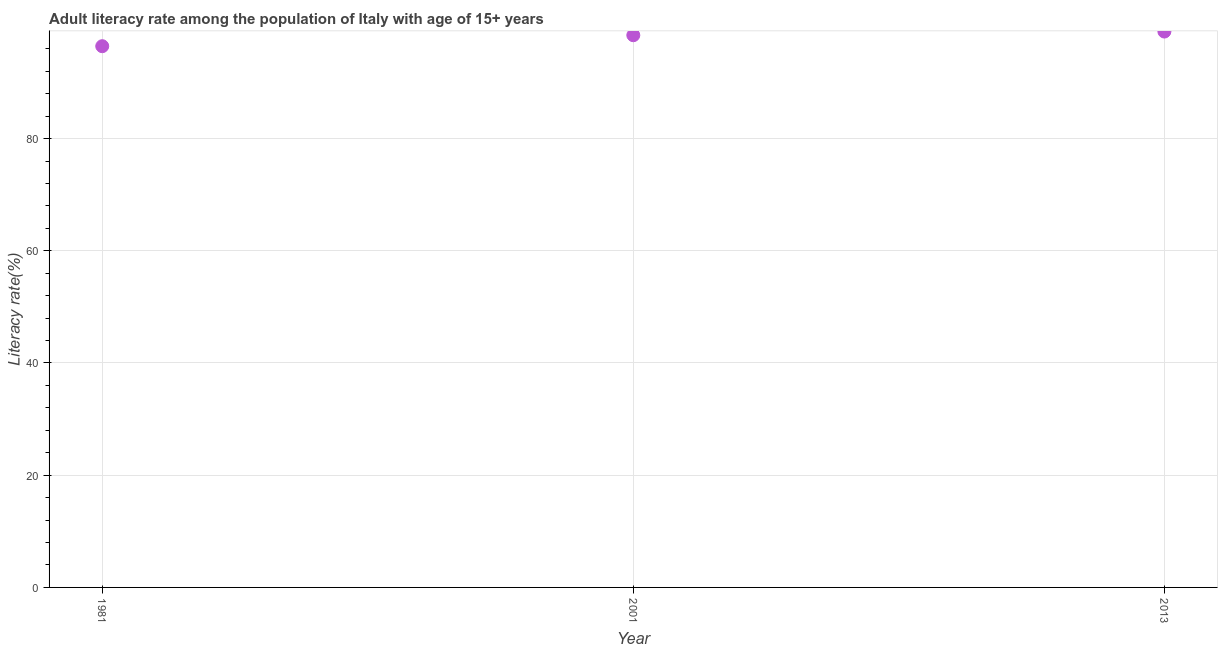What is the adult literacy rate in 2013?
Provide a short and direct response. 99.07. Across all years, what is the maximum adult literacy rate?
Offer a very short reply. 99.07. Across all years, what is the minimum adult literacy rate?
Keep it short and to the point. 96.46. In which year was the adult literacy rate maximum?
Your answer should be very brief. 2013. What is the sum of the adult literacy rate?
Provide a short and direct response. 293.95. What is the difference between the adult literacy rate in 1981 and 2001?
Provide a succinct answer. -1.96. What is the average adult literacy rate per year?
Your response must be concise. 97.98. What is the median adult literacy rate?
Your answer should be compact. 98.42. What is the ratio of the adult literacy rate in 2001 to that in 2013?
Your response must be concise. 0.99. What is the difference between the highest and the second highest adult literacy rate?
Provide a short and direct response. 0.65. Is the sum of the adult literacy rate in 1981 and 2001 greater than the maximum adult literacy rate across all years?
Offer a very short reply. Yes. What is the difference between the highest and the lowest adult literacy rate?
Provide a short and direct response. 2.61. Does the adult literacy rate monotonically increase over the years?
Provide a short and direct response. Yes. How many dotlines are there?
Provide a short and direct response. 1. What is the difference between two consecutive major ticks on the Y-axis?
Make the answer very short. 20. Does the graph contain any zero values?
Your response must be concise. No. Does the graph contain grids?
Your response must be concise. Yes. What is the title of the graph?
Make the answer very short. Adult literacy rate among the population of Italy with age of 15+ years. What is the label or title of the X-axis?
Give a very brief answer. Year. What is the label or title of the Y-axis?
Your answer should be compact. Literacy rate(%). What is the Literacy rate(%) in 1981?
Ensure brevity in your answer.  96.46. What is the Literacy rate(%) in 2001?
Make the answer very short. 98.42. What is the Literacy rate(%) in 2013?
Give a very brief answer. 99.07. What is the difference between the Literacy rate(%) in 1981 and 2001?
Make the answer very short. -1.96. What is the difference between the Literacy rate(%) in 1981 and 2013?
Ensure brevity in your answer.  -2.61. What is the difference between the Literacy rate(%) in 2001 and 2013?
Offer a very short reply. -0.65. What is the ratio of the Literacy rate(%) in 1981 to that in 2001?
Your answer should be compact. 0.98. What is the ratio of the Literacy rate(%) in 1981 to that in 2013?
Provide a succinct answer. 0.97. 